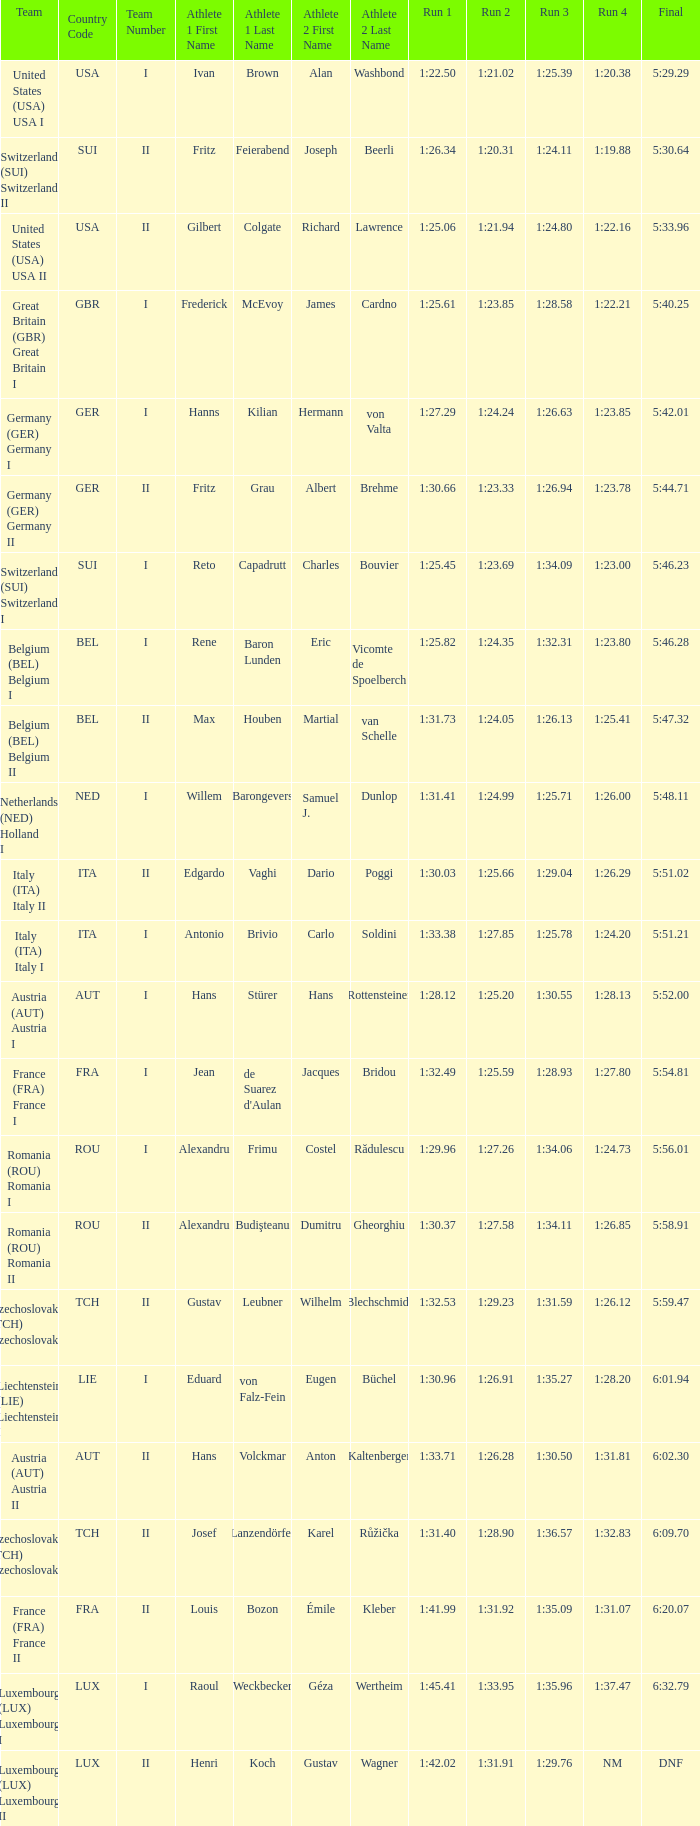Which final event has a second run time of 1:27.58? 5:58.91. 